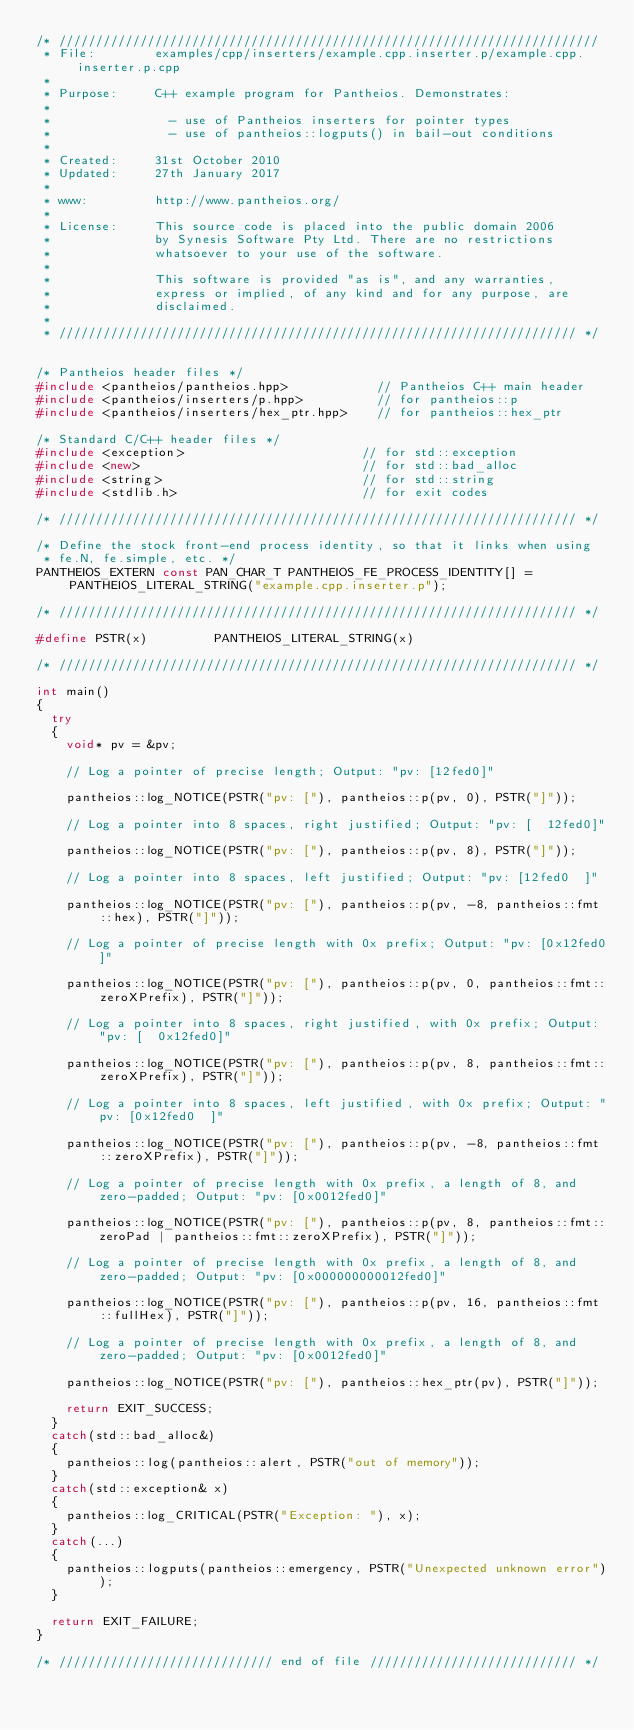Convert code to text. <code><loc_0><loc_0><loc_500><loc_500><_C++_>/* /////////////////////////////////////////////////////////////////////////
 * File:        examples/cpp/inserters/example.cpp.inserter.p/example.cpp.inserter.p.cpp
 *
 * Purpose:     C++ example program for Pantheios. Demonstrates:
 *
 *                - use of Pantheios inserters for pointer types
 *                - use of pantheios::logputs() in bail-out conditions
 *
 * Created:     31st October 2010
 * Updated:     27th January 2017
 *
 * www:         http://www.pantheios.org/
 *
 * License:     This source code is placed into the public domain 2006
 *              by Synesis Software Pty Ltd. There are no restrictions
 *              whatsoever to your use of the software.
 *
 *              This software is provided "as is", and any warranties,
 *              express or implied, of any kind and for any purpose, are
 *              disclaimed.
 *
 * ////////////////////////////////////////////////////////////////////// */


/* Pantheios header files */
#include <pantheios/pantheios.hpp>            // Pantheios C++ main header
#include <pantheios/inserters/p.hpp>          // for pantheios::p
#include <pantheios/inserters/hex_ptr.hpp>    // for pantheios::hex_ptr

/* Standard C/C++ header files */
#include <exception>                        // for std::exception
#include <new>                              // for std::bad_alloc
#include <string>                           // for std::string
#include <stdlib.h>                         // for exit codes

/* ////////////////////////////////////////////////////////////////////// */

/* Define the stock front-end process identity, so that it links when using
 * fe.N, fe.simple, etc. */
PANTHEIOS_EXTERN const PAN_CHAR_T PANTHEIOS_FE_PROCESS_IDENTITY[] = PANTHEIOS_LITERAL_STRING("example.cpp.inserter.p");

/* ////////////////////////////////////////////////////////////////////// */

#define PSTR(x)         PANTHEIOS_LITERAL_STRING(x)

/* ////////////////////////////////////////////////////////////////////// */

int main()
{
  try
  {
    void* pv = &pv;

    // Log a pointer of precise length; Output: "pv: [12fed0]"

    pantheios::log_NOTICE(PSTR("pv: ["), pantheios::p(pv, 0), PSTR("]"));

    // Log a pointer into 8 spaces, right justified; Output: "pv: [  12fed0]"

    pantheios::log_NOTICE(PSTR("pv: ["), pantheios::p(pv, 8), PSTR("]"));

    // Log a pointer into 8 spaces, left justified; Output: "pv: [12fed0  ]"

    pantheios::log_NOTICE(PSTR("pv: ["), pantheios::p(pv, -8, pantheios::fmt::hex), PSTR("]"));

    // Log a pointer of precise length with 0x prefix; Output: "pv: [0x12fed0]"

    pantheios::log_NOTICE(PSTR("pv: ["), pantheios::p(pv, 0, pantheios::fmt::zeroXPrefix), PSTR("]"));

    // Log a pointer into 8 spaces, right justified, with 0x prefix; Output: "pv: [  0x12fed0]"

    pantheios::log_NOTICE(PSTR("pv: ["), pantheios::p(pv, 8, pantheios::fmt::zeroXPrefix), PSTR("]"));

    // Log a pointer into 8 spaces, left justified, with 0x prefix; Output: "pv: [0x12fed0  ]"

    pantheios::log_NOTICE(PSTR("pv: ["), pantheios::p(pv, -8, pantheios::fmt::zeroXPrefix), PSTR("]"));

    // Log a pointer of precise length with 0x prefix, a length of 8, and zero-padded; Output: "pv: [0x0012fed0]"

    pantheios::log_NOTICE(PSTR("pv: ["), pantheios::p(pv, 8, pantheios::fmt::zeroPad | pantheios::fmt::zeroXPrefix), PSTR("]"));

    // Log a pointer of precise length with 0x prefix, a length of 8, and zero-padded; Output: "pv: [0x000000000012fed0]"

    pantheios::log_NOTICE(PSTR("pv: ["), pantheios::p(pv, 16, pantheios::fmt::fullHex), PSTR("]"));

    // Log a pointer of precise length with 0x prefix, a length of 8, and zero-padded; Output: "pv: [0x0012fed0]"

    pantheios::log_NOTICE(PSTR("pv: ["), pantheios::hex_ptr(pv), PSTR("]"));

    return EXIT_SUCCESS;
  }
  catch(std::bad_alloc&)
  {
    pantheios::log(pantheios::alert, PSTR("out of memory"));
  }
  catch(std::exception& x)
  {
    pantheios::log_CRITICAL(PSTR("Exception: "), x);
  }
  catch(...)
  {
    pantheios::logputs(pantheios::emergency, PSTR("Unexpected unknown error"));
  }

  return EXIT_FAILURE;
}

/* ///////////////////////////// end of file //////////////////////////// */
</code> 